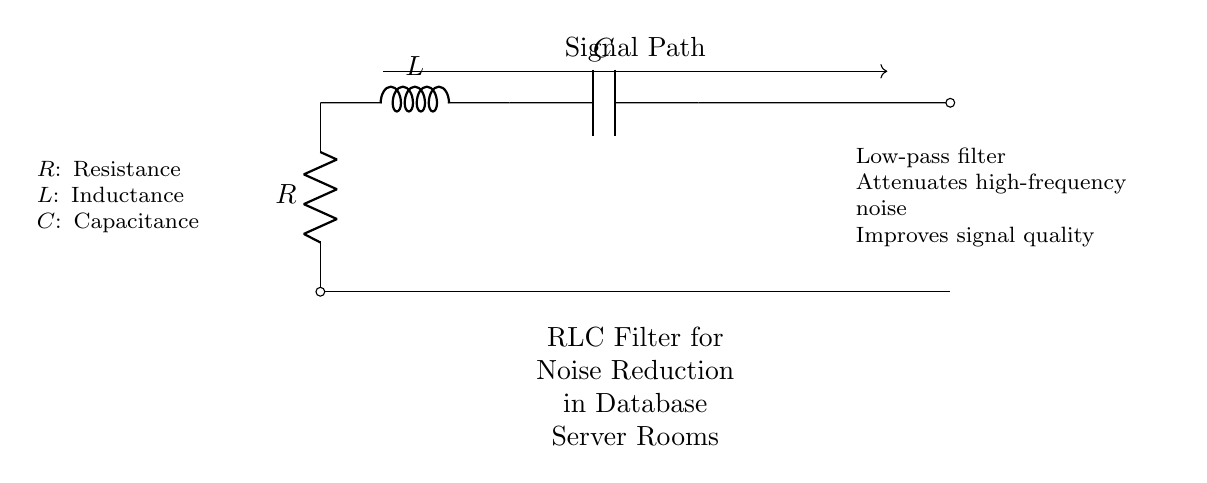What components are included in the circuit? The circuit consists of a resistor, an inductor, and a capacitor. These components are visually represented by their respective symbols in the diagram.
Answer: resistor, inductor, capacitor What type of filter is represented by this circuit? The diagram indicates that this is a low-pass filter, which means it is designed to allow low-frequency signals to pass while attenuating high-frequency signals. This is stated explicitly below the circuit.
Answer: low-pass filter What is the purpose of the RLC filter in a database server room? The purpose is to attenuate high-frequency noise, which can lead to improved signal quality in the server room. This function is specified in the description below the circuit.
Answer: noise reduction How does this circuit improve signal quality? The circuit improves signal quality by reducing high-frequency noise through its low-pass filtering effect, which prevents this noise from interfering with the desired signals in the database server room.
Answer: reduces high-frequency noise What is the relationship between resistance, inductance, and capacitance in this circuit? In an RLC circuit, the resistance (R) impacts the damping, the inductance (L) affects the circuit's response to changes in current, and the capacitance (C) relates to how it stores energy. The interplay of these components determines the filter's characteristics.
Answer: they influence signaling dynamics 